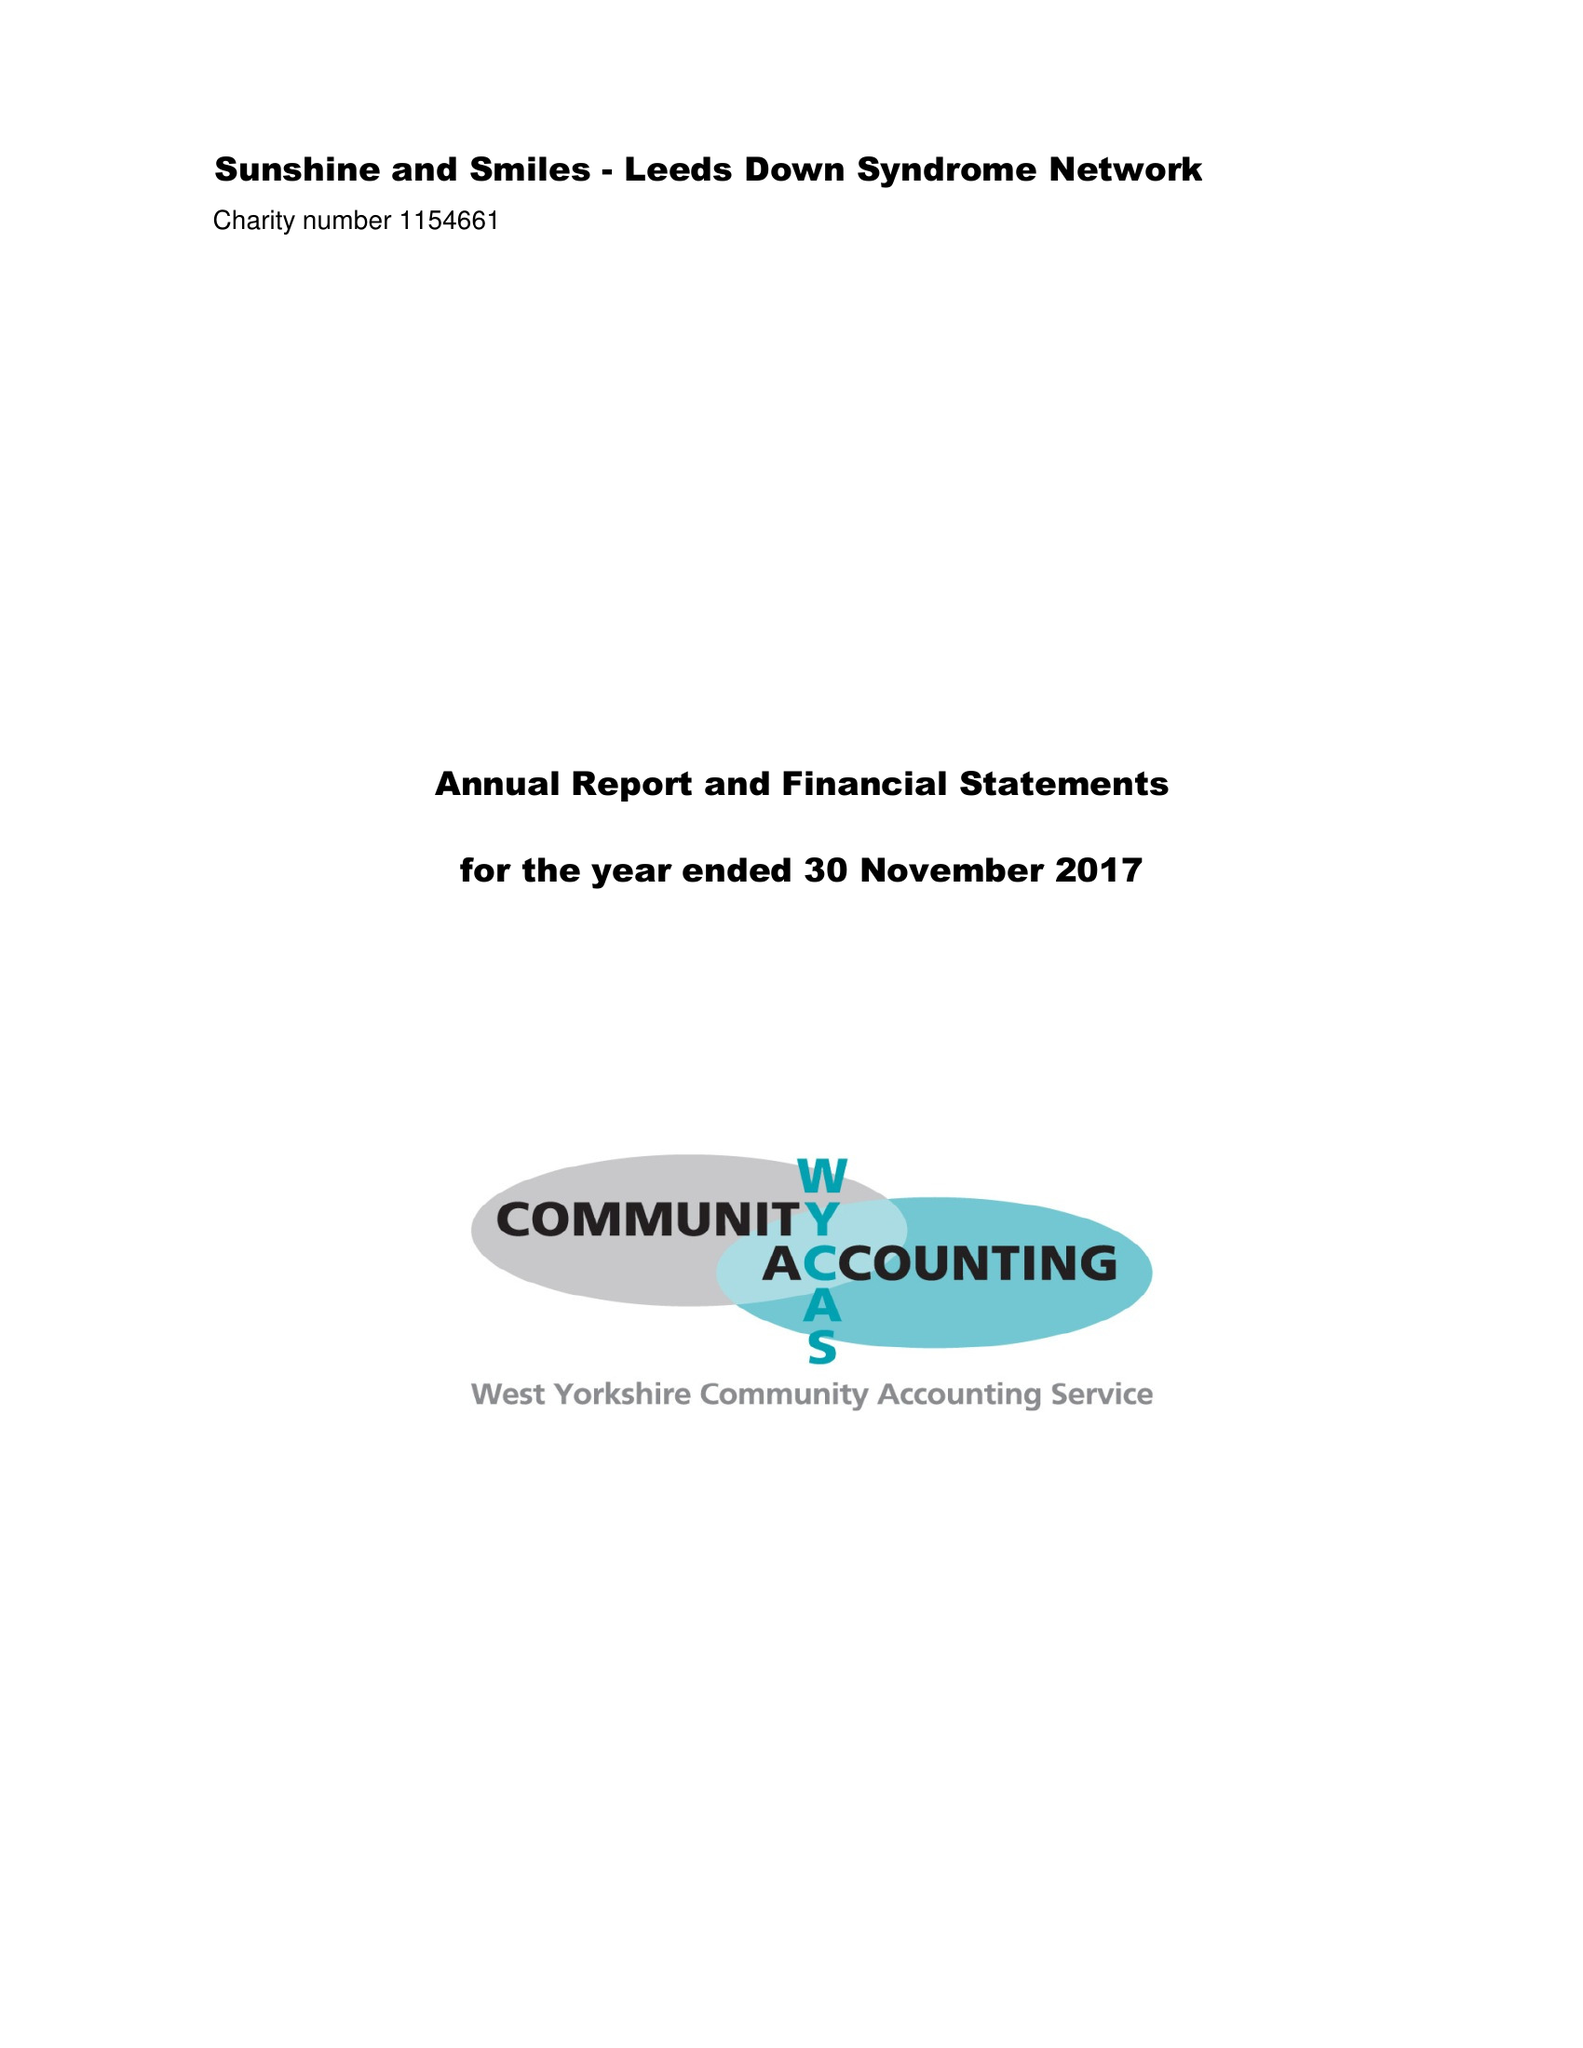What is the value for the address__post_town?
Answer the question using a single word or phrase. LEEDS 